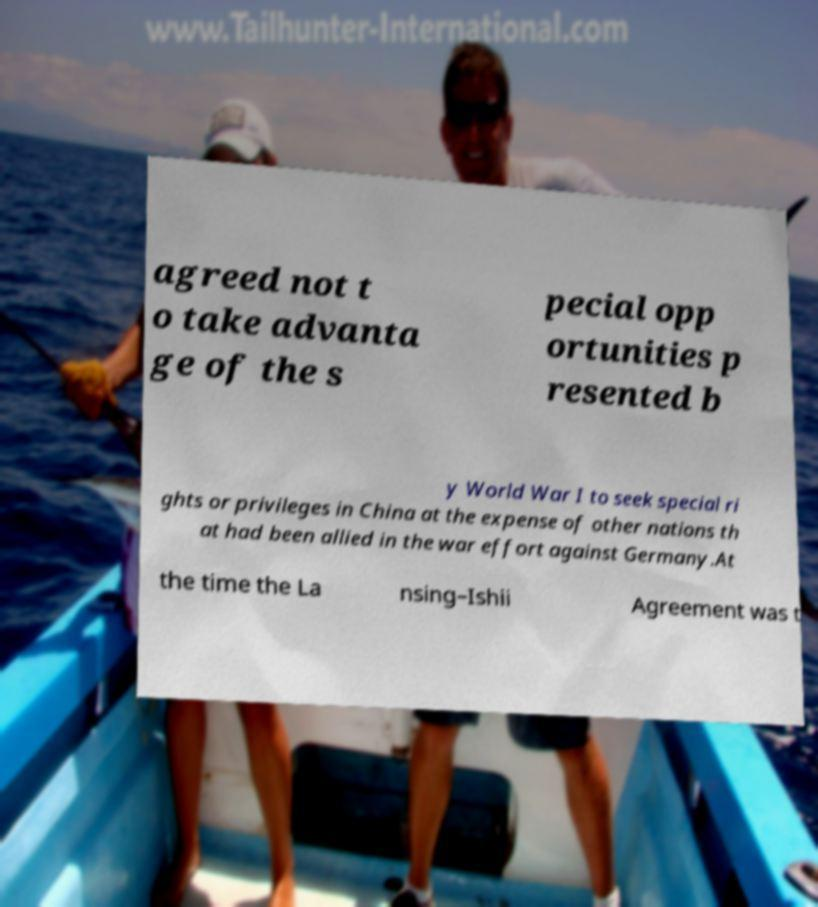For documentation purposes, I need the text within this image transcribed. Could you provide that? agreed not t o take advanta ge of the s pecial opp ortunities p resented b y World War I to seek special ri ghts or privileges in China at the expense of other nations th at had been allied in the war effort against Germany.At the time the La nsing–Ishii Agreement was t 